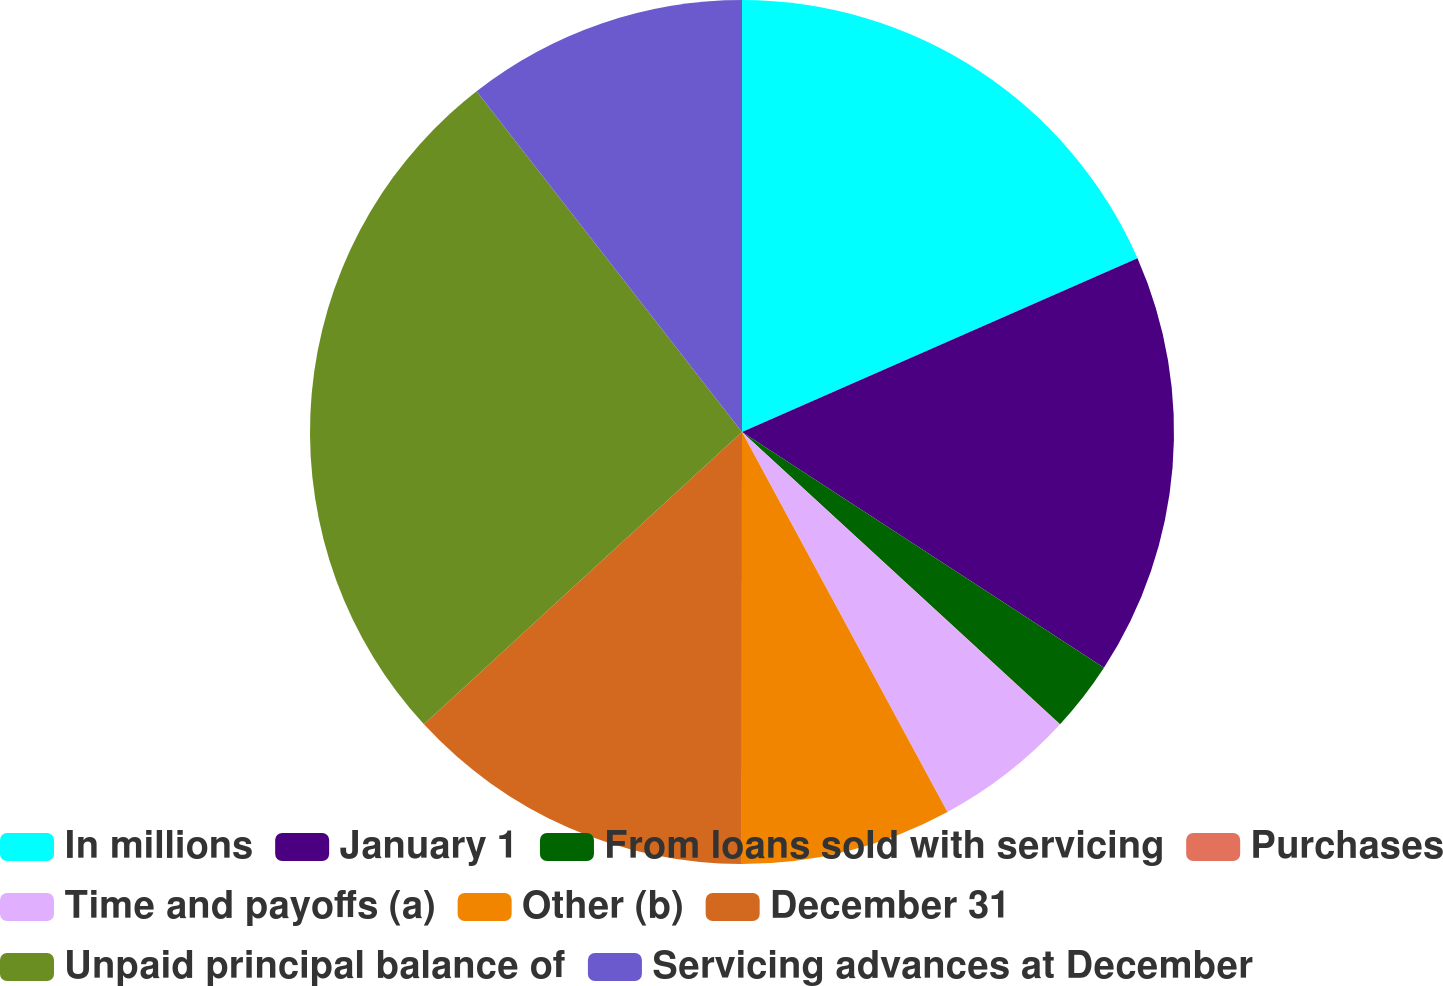Convert chart. <chart><loc_0><loc_0><loc_500><loc_500><pie_chart><fcel>In millions<fcel>January 1<fcel>From loans sold with servicing<fcel>Purchases<fcel>Time and payoffs (a)<fcel>Other (b)<fcel>December 31<fcel>Unpaid principal balance of<fcel>Servicing advances at December<nl><fcel>18.41%<fcel>15.78%<fcel>2.64%<fcel>0.01%<fcel>5.27%<fcel>7.9%<fcel>13.16%<fcel>26.3%<fcel>10.53%<nl></chart> 